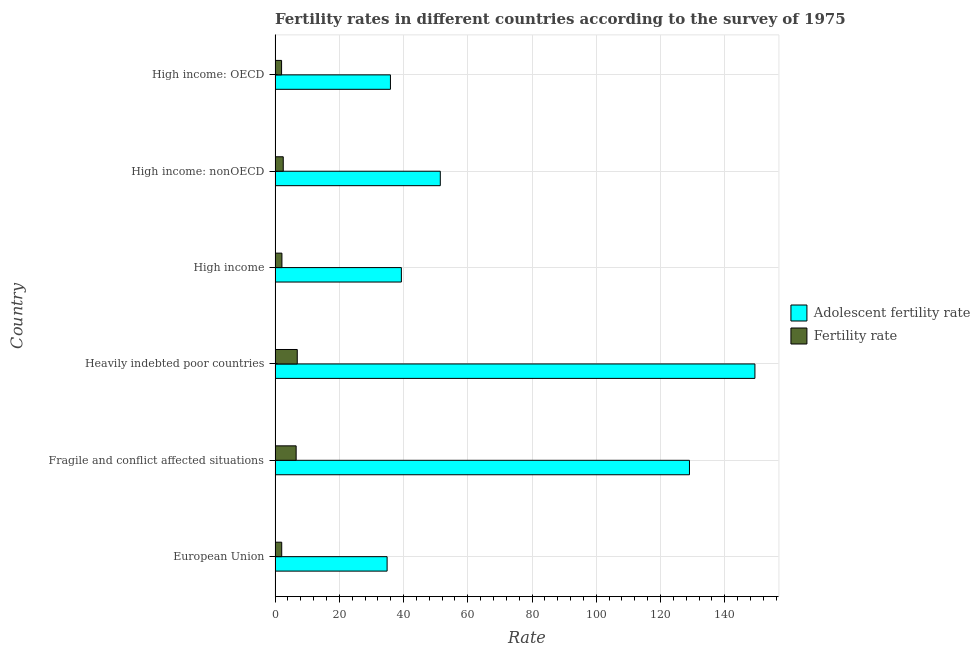How many groups of bars are there?
Give a very brief answer. 6. Are the number of bars per tick equal to the number of legend labels?
Make the answer very short. Yes. How many bars are there on the 5th tick from the bottom?
Your response must be concise. 2. What is the label of the 5th group of bars from the top?
Keep it short and to the point. Fragile and conflict affected situations. What is the fertility rate in European Union?
Offer a very short reply. 2.07. Across all countries, what is the maximum adolescent fertility rate?
Make the answer very short. 149.4. Across all countries, what is the minimum adolescent fertility rate?
Provide a short and direct response. 34.88. In which country was the fertility rate maximum?
Ensure brevity in your answer.  Heavily indebted poor countries. In which country was the fertility rate minimum?
Offer a terse response. High income: OECD. What is the total adolescent fertility rate in the graph?
Provide a succinct answer. 439.98. What is the difference between the fertility rate in Heavily indebted poor countries and that in High income?
Your response must be concise. 4.78. What is the difference between the adolescent fertility rate in Heavily indebted poor countries and the fertility rate in High income: nonOECD?
Your response must be concise. 146.85. What is the average adolescent fertility rate per country?
Ensure brevity in your answer.  73.33. What is the difference between the adolescent fertility rate and fertility rate in Heavily indebted poor countries?
Keep it short and to the point. 142.49. What is the ratio of the adolescent fertility rate in Fragile and conflict affected situations to that in High income: OECD?
Your answer should be compact. 3.59. Is the difference between the fertility rate in Fragile and conflict affected situations and Heavily indebted poor countries greater than the difference between the adolescent fertility rate in Fragile and conflict affected situations and Heavily indebted poor countries?
Provide a short and direct response. Yes. What is the difference between the highest and the second highest fertility rate?
Make the answer very short. 0.35. What is the difference between the highest and the lowest fertility rate?
Keep it short and to the point. 4.89. What does the 2nd bar from the top in High income: nonOECD represents?
Ensure brevity in your answer.  Adolescent fertility rate. What does the 1st bar from the bottom in Fragile and conflict affected situations represents?
Your answer should be very brief. Adolescent fertility rate. Are all the bars in the graph horizontal?
Give a very brief answer. Yes. Does the graph contain any zero values?
Provide a short and direct response. No. Where does the legend appear in the graph?
Offer a very short reply. Center right. How many legend labels are there?
Your answer should be compact. 2. What is the title of the graph?
Your answer should be compact. Fertility rates in different countries according to the survey of 1975. Does "Agricultural land" appear as one of the legend labels in the graph?
Give a very brief answer. No. What is the label or title of the X-axis?
Ensure brevity in your answer.  Rate. What is the label or title of the Y-axis?
Provide a succinct answer. Country. What is the Rate of Adolescent fertility rate in European Union?
Your response must be concise. 34.88. What is the Rate of Fertility rate in European Union?
Make the answer very short. 2.07. What is the Rate in Adolescent fertility rate in Fragile and conflict affected situations?
Keep it short and to the point. 129.02. What is the Rate in Fertility rate in Fragile and conflict affected situations?
Provide a short and direct response. 6.56. What is the Rate in Adolescent fertility rate in Heavily indebted poor countries?
Provide a short and direct response. 149.4. What is the Rate of Fertility rate in Heavily indebted poor countries?
Your response must be concise. 6.91. What is the Rate in Adolescent fertility rate in High income?
Offer a very short reply. 39.32. What is the Rate of Fertility rate in High income?
Keep it short and to the point. 2.13. What is the Rate of Adolescent fertility rate in High income: nonOECD?
Provide a succinct answer. 51.44. What is the Rate in Fertility rate in High income: nonOECD?
Offer a very short reply. 2.54. What is the Rate of Adolescent fertility rate in High income: OECD?
Ensure brevity in your answer.  35.91. What is the Rate in Fertility rate in High income: OECD?
Your answer should be compact. 2.02. Across all countries, what is the maximum Rate in Adolescent fertility rate?
Provide a succinct answer. 149.4. Across all countries, what is the maximum Rate in Fertility rate?
Ensure brevity in your answer.  6.91. Across all countries, what is the minimum Rate of Adolescent fertility rate?
Give a very brief answer. 34.88. Across all countries, what is the minimum Rate in Fertility rate?
Offer a very short reply. 2.02. What is the total Rate of Adolescent fertility rate in the graph?
Ensure brevity in your answer.  439.98. What is the total Rate of Fertility rate in the graph?
Make the answer very short. 22.23. What is the difference between the Rate of Adolescent fertility rate in European Union and that in Fragile and conflict affected situations?
Provide a succinct answer. -94.14. What is the difference between the Rate in Fertility rate in European Union and that in Fragile and conflict affected situations?
Ensure brevity in your answer.  -4.49. What is the difference between the Rate in Adolescent fertility rate in European Union and that in Heavily indebted poor countries?
Give a very brief answer. -114.52. What is the difference between the Rate in Fertility rate in European Union and that in Heavily indebted poor countries?
Offer a very short reply. -4.84. What is the difference between the Rate in Adolescent fertility rate in European Union and that in High income?
Ensure brevity in your answer.  -4.44. What is the difference between the Rate in Fertility rate in European Union and that in High income?
Offer a terse response. -0.07. What is the difference between the Rate of Adolescent fertility rate in European Union and that in High income: nonOECD?
Your answer should be compact. -16.56. What is the difference between the Rate in Fertility rate in European Union and that in High income: nonOECD?
Your answer should be very brief. -0.48. What is the difference between the Rate of Adolescent fertility rate in European Union and that in High income: OECD?
Ensure brevity in your answer.  -1.04. What is the difference between the Rate of Fertility rate in European Union and that in High income: OECD?
Make the answer very short. 0.04. What is the difference between the Rate in Adolescent fertility rate in Fragile and conflict affected situations and that in Heavily indebted poor countries?
Offer a terse response. -20.38. What is the difference between the Rate of Fertility rate in Fragile and conflict affected situations and that in Heavily indebted poor countries?
Your answer should be compact. -0.35. What is the difference between the Rate of Adolescent fertility rate in Fragile and conflict affected situations and that in High income?
Provide a succinct answer. 89.7. What is the difference between the Rate in Fertility rate in Fragile and conflict affected situations and that in High income?
Offer a terse response. 4.43. What is the difference between the Rate of Adolescent fertility rate in Fragile and conflict affected situations and that in High income: nonOECD?
Your response must be concise. 77.58. What is the difference between the Rate in Fertility rate in Fragile and conflict affected situations and that in High income: nonOECD?
Keep it short and to the point. 4.01. What is the difference between the Rate in Adolescent fertility rate in Fragile and conflict affected situations and that in High income: OECD?
Provide a succinct answer. 93.11. What is the difference between the Rate of Fertility rate in Fragile and conflict affected situations and that in High income: OECD?
Give a very brief answer. 4.54. What is the difference between the Rate of Adolescent fertility rate in Heavily indebted poor countries and that in High income?
Offer a terse response. 110.08. What is the difference between the Rate of Fertility rate in Heavily indebted poor countries and that in High income?
Offer a very short reply. 4.78. What is the difference between the Rate in Adolescent fertility rate in Heavily indebted poor countries and that in High income: nonOECD?
Your answer should be compact. 97.96. What is the difference between the Rate in Fertility rate in Heavily indebted poor countries and that in High income: nonOECD?
Your answer should be compact. 4.36. What is the difference between the Rate in Adolescent fertility rate in Heavily indebted poor countries and that in High income: OECD?
Your response must be concise. 113.48. What is the difference between the Rate of Fertility rate in Heavily indebted poor countries and that in High income: OECD?
Provide a short and direct response. 4.89. What is the difference between the Rate in Adolescent fertility rate in High income and that in High income: nonOECD?
Offer a terse response. -12.12. What is the difference between the Rate in Fertility rate in High income and that in High income: nonOECD?
Provide a succinct answer. -0.41. What is the difference between the Rate of Adolescent fertility rate in High income and that in High income: OECD?
Provide a short and direct response. 3.41. What is the difference between the Rate of Fertility rate in High income and that in High income: OECD?
Your answer should be very brief. 0.11. What is the difference between the Rate in Adolescent fertility rate in High income: nonOECD and that in High income: OECD?
Give a very brief answer. 15.53. What is the difference between the Rate in Fertility rate in High income: nonOECD and that in High income: OECD?
Your answer should be very brief. 0.52. What is the difference between the Rate of Adolescent fertility rate in European Union and the Rate of Fertility rate in Fragile and conflict affected situations?
Provide a short and direct response. 28.32. What is the difference between the Rate of Adolescent fertility rate in European Union and the Rate of Fertility rate in Heavily indebted poor countries?
Ensure brevity in your answer.  27.97. What is the difference between the Rate in Adolescent fertility rate in European Union and the Rate in Fertility rate in High income?
Keep it short and to the point. 32.75. What is the difference between the Rate in Adolescent fertility rate in European Union and the Rate in Fertility rate in High income: nonOECD?
Give a very brief answer. 32.33. What is the difference between the Rate in Adolescent fertility rate in European Union and the Rate in Fertility rate in High income: OECD?
Ensure brevity in your answer.  32.86. What is the difference between the Rate in Adolescent fertility rate in Fragile and conflict affected situations and the Rate in Fertility rate in Heavily indebted poor countries?
Make the answer very short. 122.11. What is the difference between the Rate of Adolescent fertility rate in Fragile and conflict affected situations and the Rate of Fertility rate in High income?
Your answer should be compact. 126.89. What is the difference between the Rate of Adolescent fertility rate in Fragile and conflict affected situations and the Rate of Fertility rate in High income: nonOECD?
Ensure brevity in your answer.  126.48. What is the difference between the Rate of Adolescent fertility rate in Fragile and conflict affected situations and the Rate of Fertility rate in High income: OECD?
Offer a very short reply. 127. What is the difference between the Rate of Adolescent fertility rate in Heavily indebted poor countries and the Rate of Fertility rate in High income?
Your answer should be compact. 147.27. What is the difference between the Rate in Adolescent fertility rate in Heavily indebted poor countries and the Rate in Fertility rate in High income: nonOECD?
Keep it short and to the point. 146.85. What is the difference between the Rate in Adolescent fertility rate in Heavily indebted poor countries and the Rate in Fertility rate in High income: OECD?
Your response must be concise. 147.38. What is the difference between the Rate in Adolescent fertility rate in High income and the Rate in Fertility rate in High income: nonOECD?
Your answer should be compact. 36.78. What is the difference between the Rate in Adolescent fertility rate in High income and the Rate in Fertility rate in High income: OECD?
Give a very brief answer. 37.3. What is the difference between the Rate in Adolescent fertility rate in High income: nonOECD and the Rate in Fertility rate in High income: OECD?
Your response must be concise. 49.42. What is the average Rate in Adolescent fertility rate per country?
Make the answer very short. 73.33. What is the average Rate of Fertility rate per country?
Ensure brevity in your answer.  3.7. What is the difference between the Rate in Adolescent fertility rate and Rate in Fertility rate in European Union?
Your answer should be very brief. 32.81. What is the difference between the Rate in Adolescent fertility rate and Rate in Fertility rate in Fragile and conflict affected situations?
Offer a very short reply. 122.46. What is the difference between the Rate of Adolescent fertility rate and Rate of Fertility rate in Heavily indebted poor countries?
Provide a short and direct response. 142.49. What is the difference between the Rate in Adolescent fertility rate and Rate in Fertility rate in High income?
Your answer should be very brief. 37.19. What is the difference between the Rate in Adolescent fertility rate and Rate in Fertility rate in High income: nonOECD?
Your response must be concise. 48.9. What is the difference between the Rate in Adolescent fertility rate and Rate in Fertility rate in High income: OECD?
Provide a succinct answer. 33.89. What is the ratio of the Rate in Adolescent fertility rate in European Union to that in Fragile and conflict affected situations?
Keep it short and to the point. 0.27. What is the ratio of the Rate in Fertility rate in European Union to that in Fragile and conflict affected situations?
Give a very brief answer. 0.31. What is the ratio of the Rate of Adolescent fertility rate in European Union to that in Heavily indebted poor countries?
Provide a succinct answer. 0.23. What is the ratio of the Rate of Fertility rate in European Union to that in Heavily indebted poor countries?
Offer a very short reply. 0.3. What is the ratio of the Rate in Adolescent fertility rate in European Union to that in High income?
Offer a very short reply. 0.89. What is the ratio of the Rate of Fertility rate in European Union to that in High income?
Your answer should be very brief. 0.97. What is the ratio of the Rate in Adolescent fertility rate in European Union to that in High income: nonOECD?
Your answer should be compact. 0.68. What is the ratio of the Rate in Fertility rate in European Union to that in High income: nonOECD?
Provide a short and direct response. 0.81. What is the ratio of the Rate of Adolescent fertility rate in European Union to that in High income: OECD?
Offer a very short reply. 0.97. What is the ratio of the Rate in Fertility rate in European Union to that in High income: OECD?
Keep it short and to the point. 1.02. What is the ratio of the Rate in Adolescent fertility rate in Fragile and conflict affected situations to that in Heavily indebted poor countries?
Your answer should be compact. 0.86. What is the ratio of the Rate in Fertility rate in Fragile and conflict affected situations to that in Heavily indebted poor countries?
Ensure brevity in your answer.  0.95. What is the ratio of the Rate of Adolescent fertility rate in Fragile and conflict affected situations to that in High income?
Your answer should be compact. 3.28. What is the ratio of the Rate of Fertility rate in Fragile and conflict affected situations to that in High income?
Your response must be concise. 3.08. What is the ratio of the Rate of Adolescent fertility rate in Fragile and conflict affected situations to that in High income: nonOECD?
Make the answer very short. 2.51. What is the ratio of the Rate of Fertility rate in Fragile and conflict affected situations to that in High income: nonOECD?
Ensure brevity in your answer.  2.58. What is the ratio of the Rate of Adolescent fertility rate in Fragile and conflict affected situations to that in High income: OECD?
Offer a very short reply. 3.59. What is the ratio of the Rate in Fertility rate in Fragile and conflict affected situations to that in High income: OECD?
Offer a very short reply. 3.24. What is the ratio of the Rate of Adolescent fertility rate in Heavily indebted poor countries to that in High income?
Ensure brevity in your answer.  3.8. What is the ratio of the Rate in Fertility rate in Heavily indebted poor countries to that in High income?
Provide a succinct answer. 3.24. What is the ratio of the Rate in Adolescent fertility rate in Heavily indebted poor countries to that in High income: nonOECD?
Keep it short and to the point. 2.9. What is the ratio of the Rate in Fertility rate in Heavily indebted poor countries to that in High income: nonOECD?
Ensure brevity in your answer.  2.72. What is the ratio of the Rate of Adolescent fertility rate in Heavily indebted poor countries to that in High income: OECD?
Offer a terse response. 4.16. What is the ratio of the Rate in Fertility rate in Heavily indebted poor countries to that in High income: OECD?
Offer a very short reply. 3.42. What is the ratio of the Rate of Adolescent fertility rate in High income to that in High income: nonOECD?
Your answer should be compact. 0.76. What is the ratio of the Rate of Fertility rate in High income to that in High income: nonOECD?
Your answer should be very brief. 0.84. What is the ratio of the Rate of Adolescent fertility rate in High income to that in High income: OECD?
Offer a terse response. 1.09. What is the ratio of the Rate of Fertility rate in High income to that in High income: OECD?
Your answer should be compact. 1.05. What is the ratio of the Rate of Adolescent fertility rate in High income: nonOECD to that in High income: OECD?
Ensure brevity in your answer.  1.43. What is the ratio of the Rate of Fertility rate in High income: nonOECD to that in High income: OECD?
Your answer should be very brief. 1.26. What is the difference between the highest and the second highest Rate in Adolescent fertility rate?
Offer a terse response. 20.38. What is the difference between the highest and the second highest Rate in Fertility rate?
Offer a terse response. 0.35. What is the difference between the highest and the lowest Rate of Adolescent fertility rate?
Keep it short and to the point. 114.52. What is the difference between the highest and the lowest Rate in Fertility rate?
Offer a terse response. 4.89. 